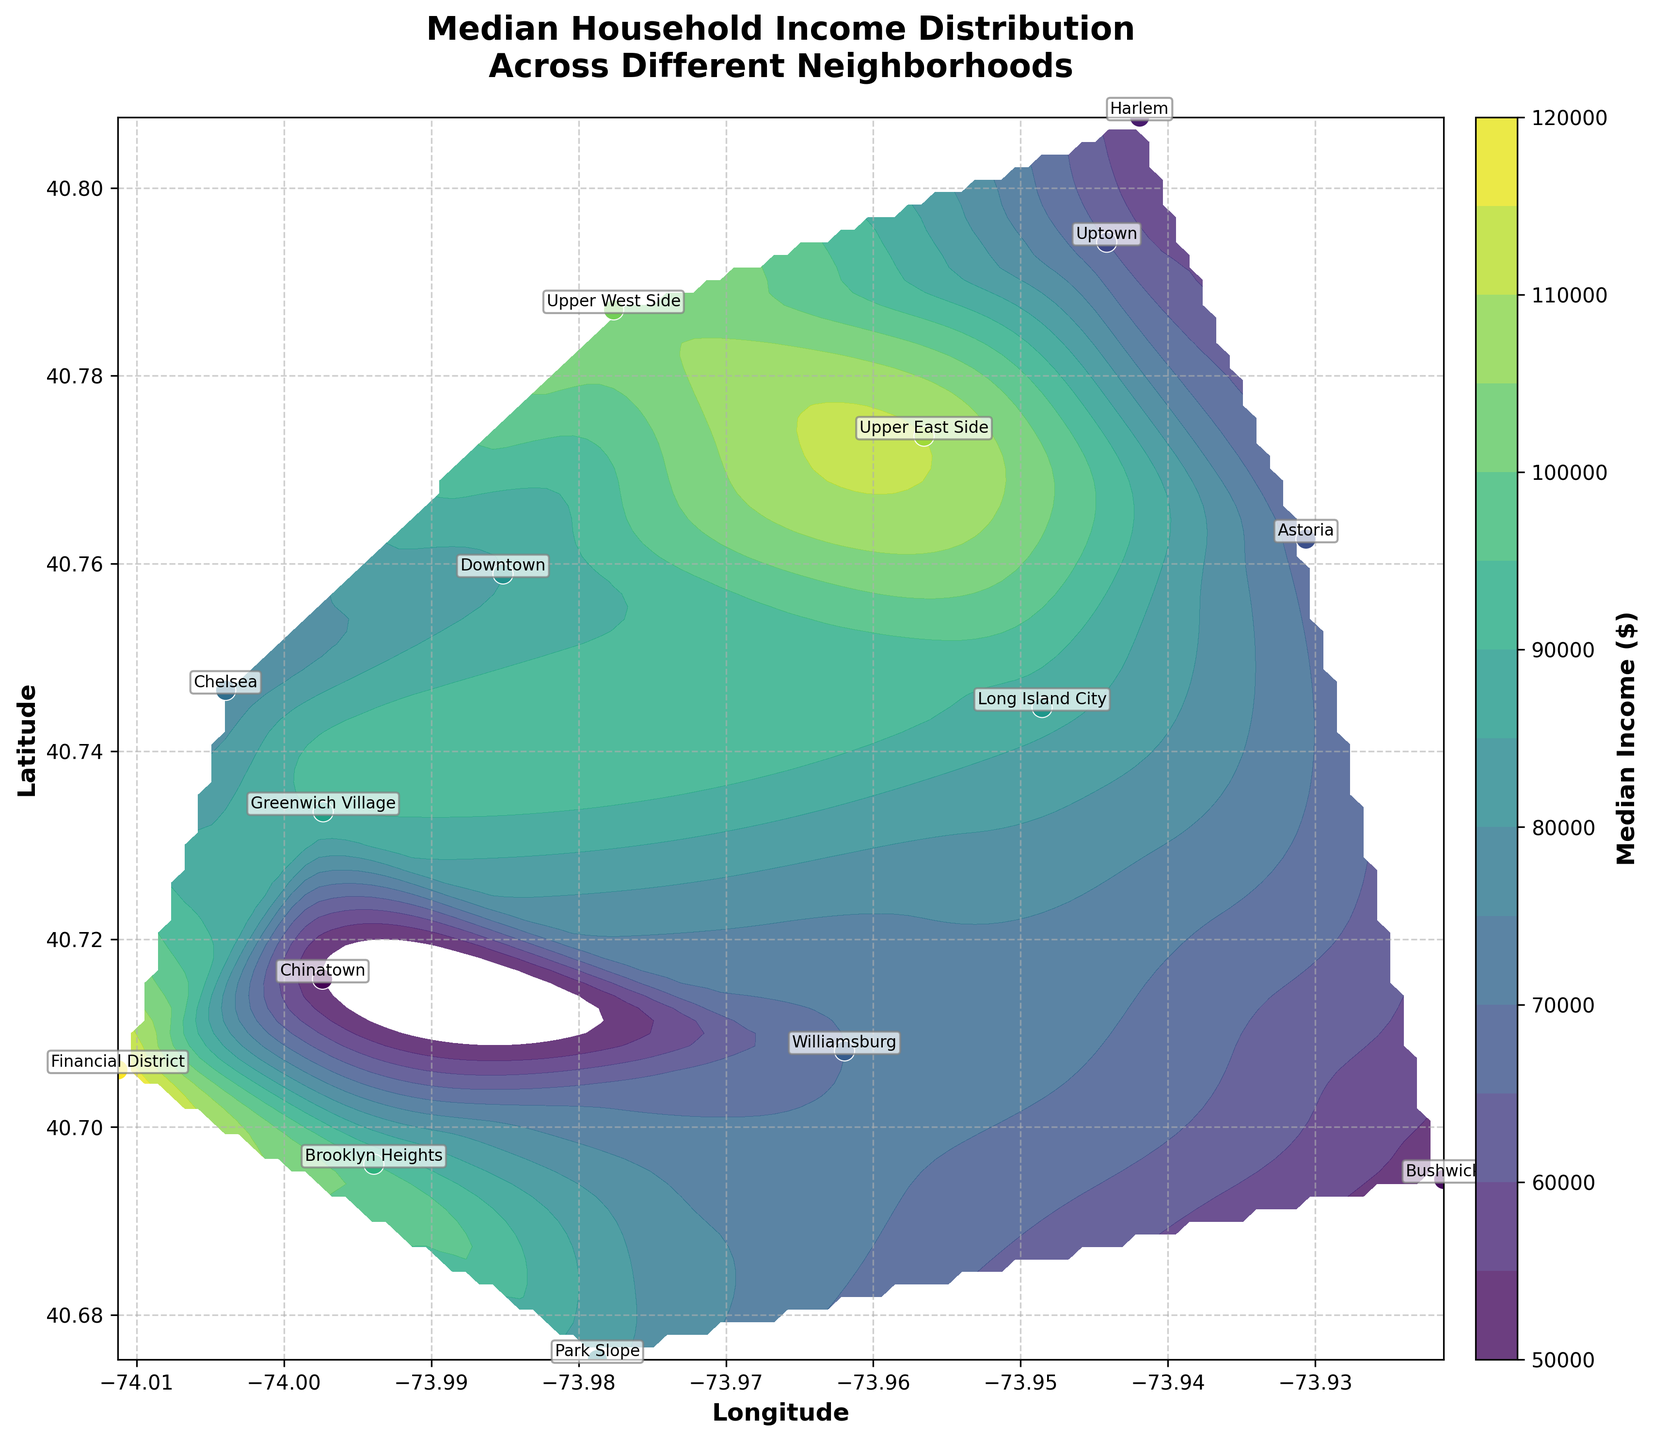What is the median household income in the Downtown neighborhood? Look at the labeled scatter point in Downtown on the contour plot and refer to its color in the legend on the color bar, which shows median incomes.
Answer: $85,000 What is the range of the median household incomes shown in the plot? Check the minimum and maximum values on the color bar, which indicates the range of median incomes.
Answer: $50,000 to $120,000 Which neighborhood has the highest median household income? Identify the scatter point with the darkest shade (indicating highest income) and refer to the label next to it.
Answer: Financial District From which neighborhood to which neighborhood does the median income drop most significantly? Compare the colors of the scatter points on the contour plot and note the largest color difference between any two neighborhoods by checking the corresponding labels.
Answer: Financial District to Chinatown How is the median income gradient distributed from east to west across neighborhoods? Examine the contour lines and shades from east to west (i.e., left to right on the plot) and observe the coloring pattern which shows the variations.
Answer: Generally decreases, with a high concentration in the west Which neighborhoods are clustered together with similar median household incomes? Look for clusters with similar shades and refer to the labels next to these points to identify the neighborhoods.
Answer: Harlem and Bushwick What is the median household income in the Upper East Side compared to the Upper West Side? Compare the scatter points for Upper East Side and Upper West Side, referring to their respective colors and cross-reference with the values on the color bar.
Answer: Upper East Side: $110,000, Upper West Side: $105,000 What is the average median household income of the neighborhoods in Brooklyn in the plot? Identify Brooklyn neighborhoods (Williamsburg, Brooklyn Heights, Park Slope, Bushwick), sum their median household incomes, and divide by the number of neighborhoods.
Answer: ($70,000 + $95,000 + $82,000 + $52,000) / 4 = $74,750 